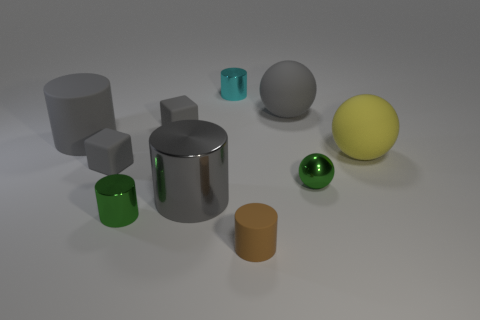Does the yellow sphere have the same size as the green cylinder?
Your response must be concise. No. How many objects are both left of the small brown matte thing and to the right of the green ball?
Offer a very short reply. 0. How many yellow things are big rubber objects or small matte blocks?
Provide a short and direct response. 1. What number of shiny things are small cubes or small cylinders?
Keep it short and to the point. 2. Are there any big green blocks?
Make the answer very short. No. Do the brown rubber object and the big yellow thing have the same shape?
Your answer should be compact. No. How many large gray rubber objects are to the left of the tiny green object to the right of the gray thing right of the brown thing?
Keep it short and to the point. 2. There is a big gray object that is both left of the gray matte sphere and behind the tiny metallic ball; what material is it?
Provide a short and direct response. Rubber. The large object that is to the left of the small brown matte object and behind the small green metal sphere is what color?
Provide a succinct answer. Gray. Is there anything else that is the same color as the small matte cylinder?
Provide a succinct answer. No. 